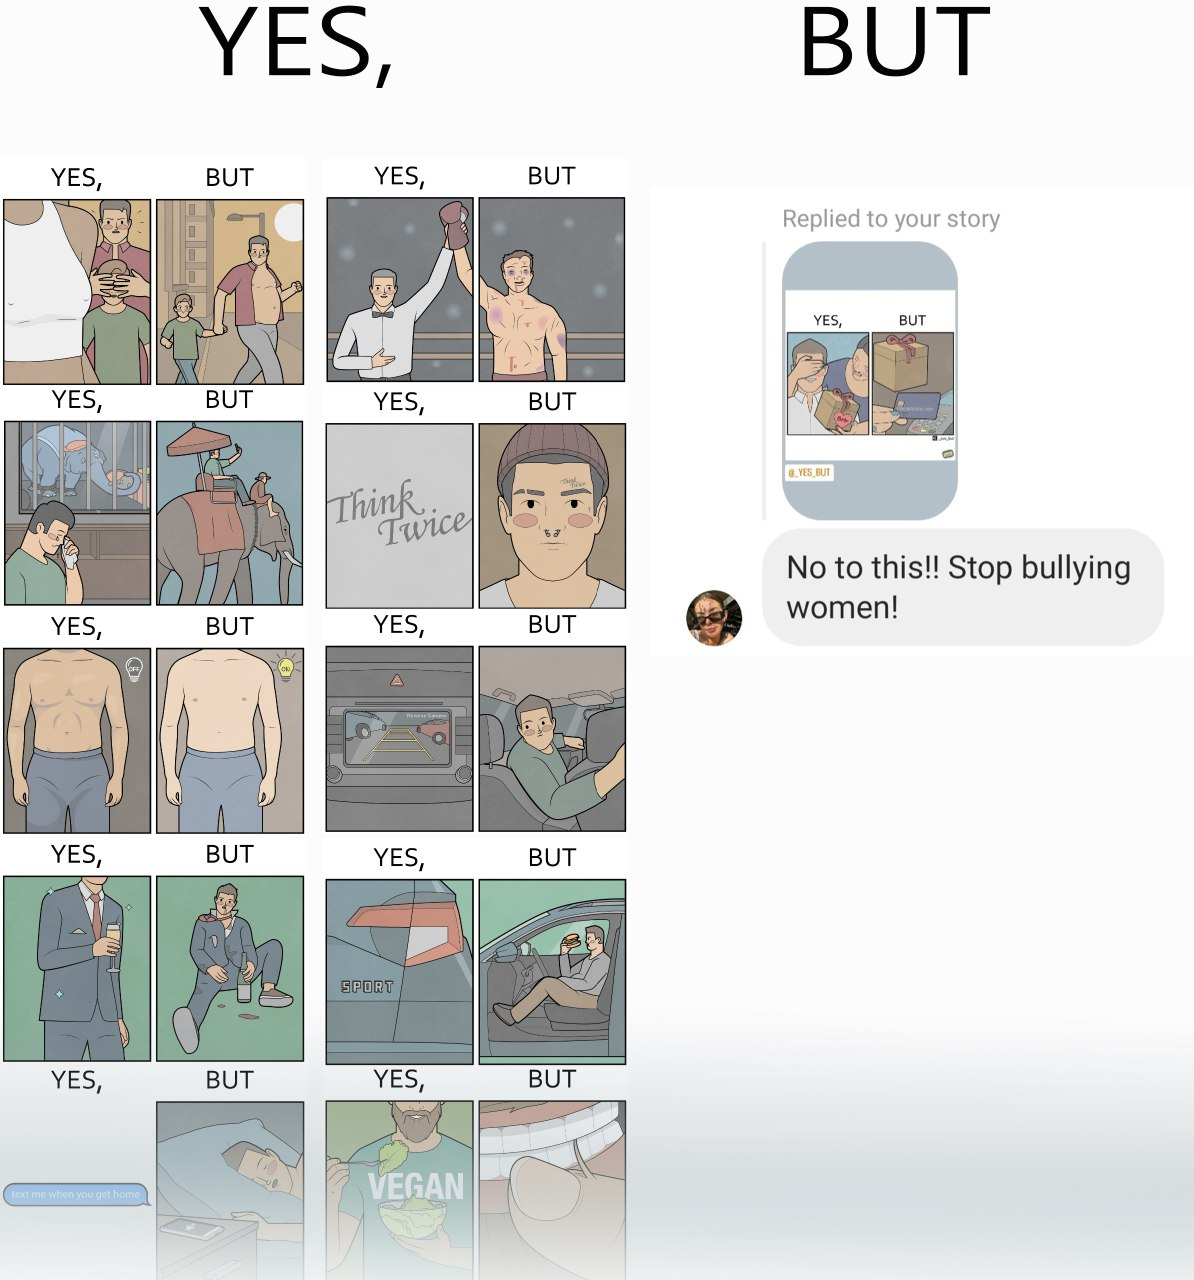Explain why this image is satirical. The image is ironic, because in the first image there are many memes on men but in the second image a person is seen raising voice over some meme on woman and calling it as woman bully but no one raises their voice against memes over man calling them as man bully 